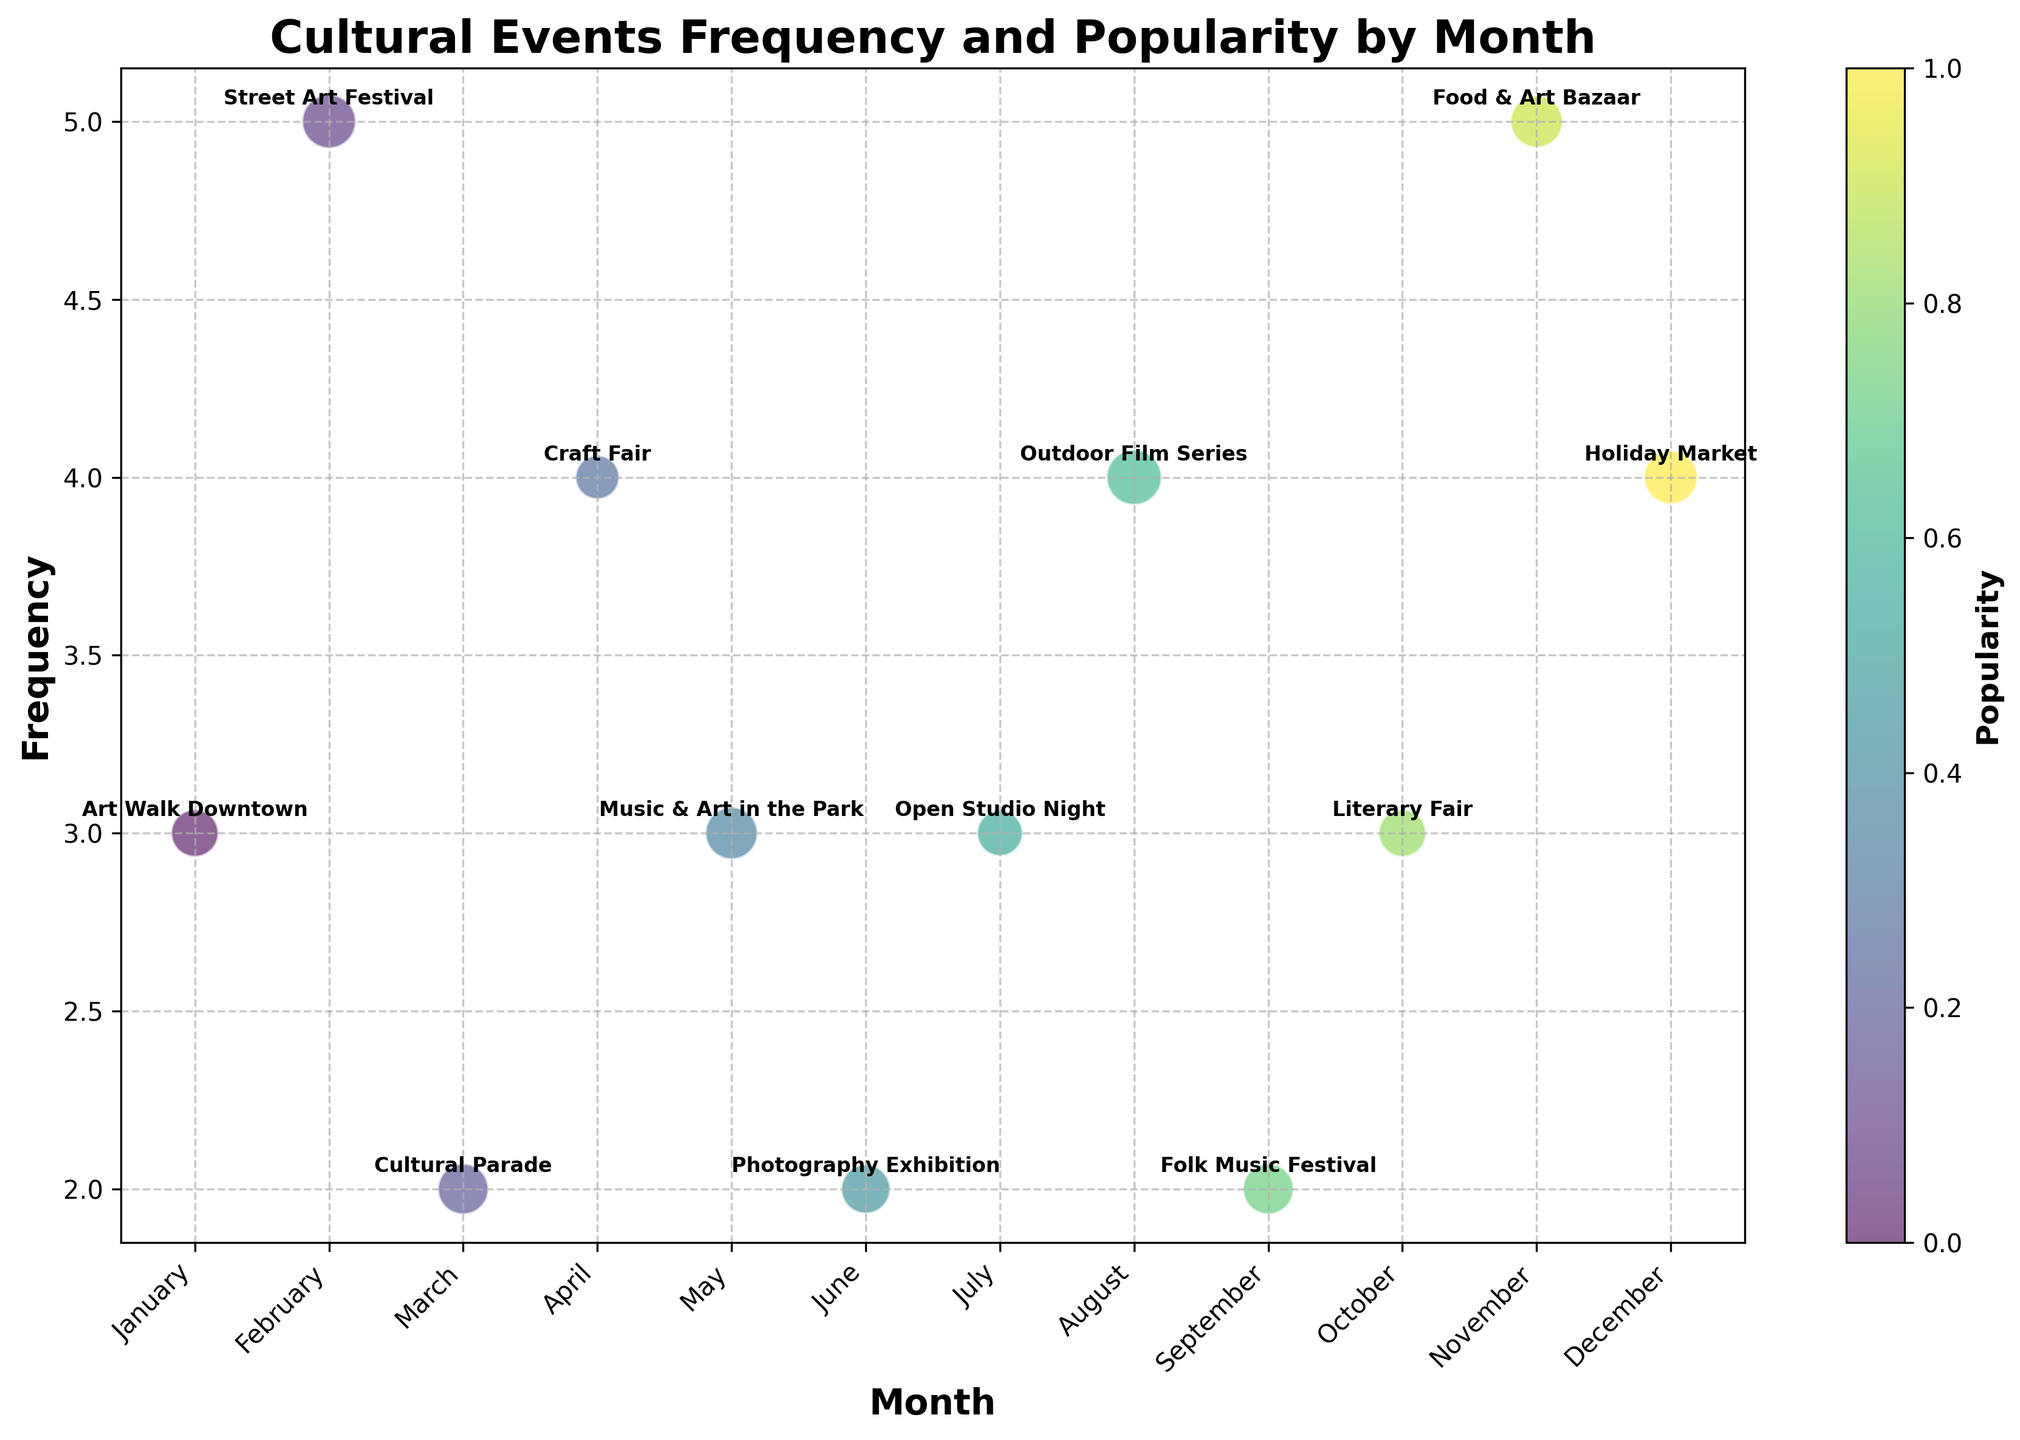What is the title of the chart? The title of the chart is displayed at the top of the figure.
Answer: Cultural Events Frequency and Popularity by Month What does the x-axis represent? The x-axis represents the months of the year, ranging from January to December.
Answer: Months Which event has the highest popularity in August? Look for the bubble in August and check which event is labeled.
Answer: Outdoor Film Series What is the frequency of the Street Art Festival, and in which month does it occur? Locate the Street Art Festival bubble and read the corresponding y-value for frequency and x-value for the month.
Answer: 5 in February How many events occur with a frequency of 4? Count the number of bubbles placed at the y-value of 4.
Answer: 3 events Which event has the largest bubble size, and what does this signify? Identify the event with the largest bubble and understand that size indicates popularity.
Answer: Outdoor Film Series; it signifies the highest popularity Compare the frequency and popularity of the Holiday Market and the Food & Art Bazaar. Locate the bubbles for both events and observe their positions and sizes/labels.
Answer: Holiday Market has 4 frequency and 90 popularity; Food & Art Bazaar has 5 frequency and 85 popularity What is the total frequency of events occurring with a popularity greater than 80? Identify bubbles with sizes indicating popularity > 80 and sum their frequencies.
Answer: Street Art Festival (5), Cultural Parade (2), Music & Art in the Park (3), Outdoor Film Series (4), Holiday Market (4); Total: 18 Which event occurs in April, and what's its popularity? Identify the bubble corresponding to April and read the event label and bubble size.
Answer: Craft Fair; 60 Do any events have the same frequency and popularity levels? If so, name them. Compare each event's frequency and popularity, checking for matches.
Answer: Cultural Parade and Folk Music Festival both have frequency 2 and popularity 80 